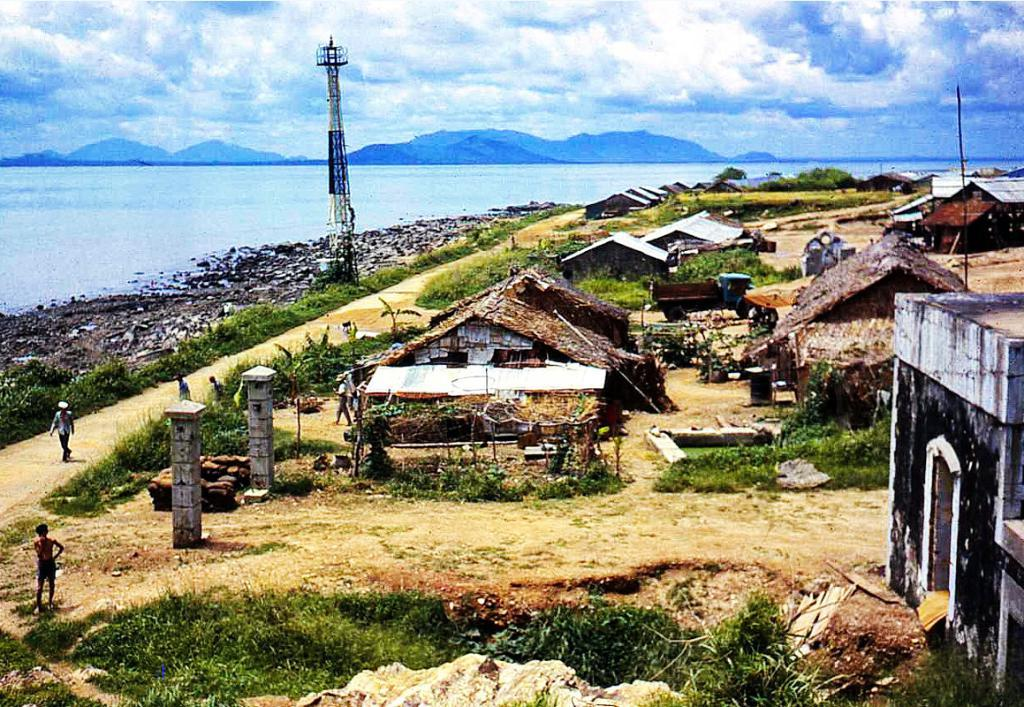What are the people in the image doing? The people in the image are walking on a path. What type of structures can be seen in the image? There are houses in the image. What other natural elements are present in the image? There are plants in the image. What is the tallest structure in the image? There is a tower in the image. What can be seen in the distance in the image? The background of the image includes the sea and mountains. What part of the natural environment is visible in the image? The sky is visible in the background of the image. What type of car are the friends driving in the image? There are no cars or friends present in the image; it features people walking on a path and various structures and natural elements. 